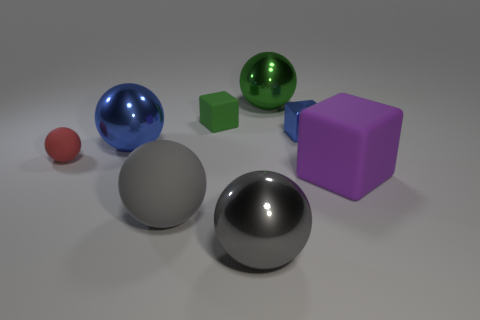Is the number of blue shiny cubes on the right side of the small green matte thing greater than the number of tiny matte cylinders?
Your answer should be compact. Yes. Is there a shiny thing that has the same color as the tiny metal block?
Provide a succinct answer. Yes. There is a rubber ball that is the same size as the green shiny sphere; what is its color?
Provide a short and direct response. Gray. What number of large metallic objects are behind the large shiny object in front of the tiny ball?
Ensure brevity in your answer.  2. What number of things are blue shiny balls to the left of the tiny metal block or metal balls?
Offer a very short reply. 3. What number of large gray balls are the same material as the tiny red sphere?
Offer a terse response. 1. What shape is the other object that is the same color as the small shiny object?
Offer a very short reply. Sphere. Are there the same number of purple cubes that are left of the big blue object and big gray blocks?
Give a very brief answer. Yes. What is the size of the blue thing on the right side of the tiny green rubber block?
Keep it short and to the point. Small. How many large objects are green cubes or red objects?
Provide a short and direct response. 0. 